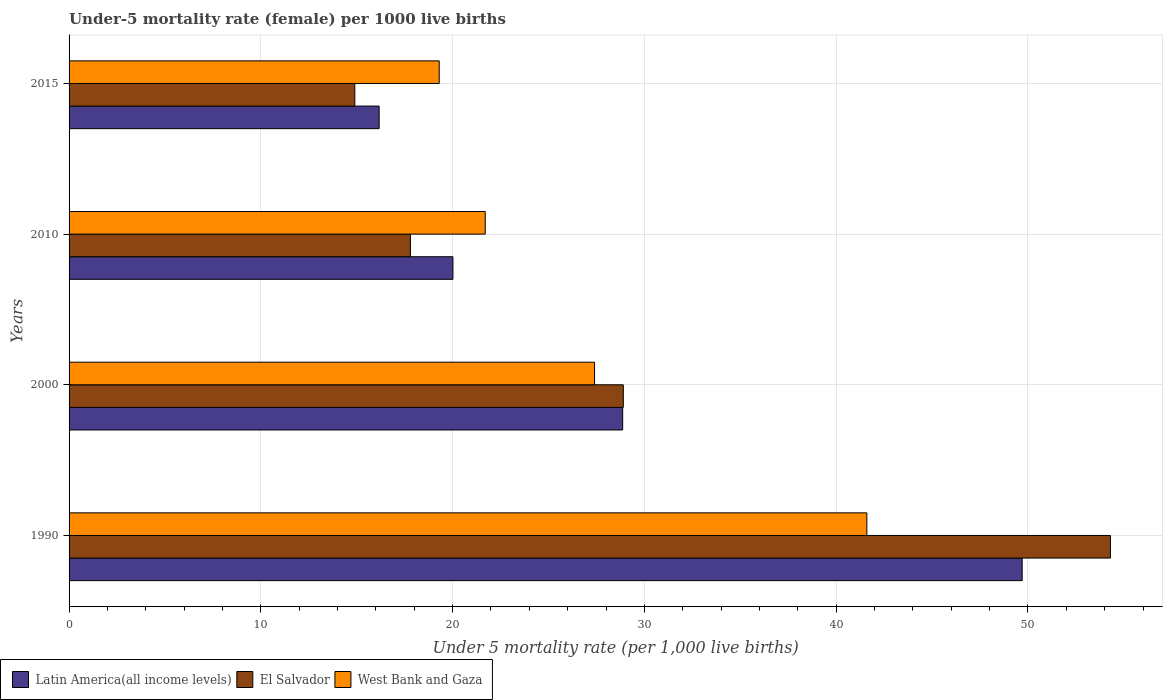Are the number of bars per tick equal to the number of legend labels?
Keep it short and to the point. Yes. How many bars are there on the 4th tick from the bottom?
Provide a short and direct response. 3. What is the label of the 2nd group of bars from the top?
Ensure brevity in your answer.  2010. In how many cases, is the number of bars for a given year not equal to the number of legend labels?
Your answer should be very brief. 0. What is the under-five mortality rate in Latin America(all income levels) in 2015?
Give a very brief answer. 16.17. Across all years, what is the maximum under-five mortality rate in Latin America(all income levels)?
Provide a succinct answer. 49.7. Across all years, what is the minimum under-five mortality rate in Latin America(all income levels)?
Provide a succinct answer. 16.17. In which year was the under-five mortality rate in West Bank and Gaza minimum?
Provide a short and direct response. 2015. What is the total under-five mortality rate in El Salvador in the graph?
Your answer should be compact. 115.9. What is the difference between the under-five mortality rate in El Salvador in 1990 and that in 2010?
Ensure brevity in your answer.  36.5. What is the difference between the under-five mortality rate in El Salvador in 1990 and the under-five mortality rate in West Bank and Gaza in 2010?
Keep it short and to the point. 32.6. What is the average under-five mortality rate in El Salvador per year?
Offer a terse response. 28.97. In the year 2015, what is the difference between the under-five mortality rate in El Salvador and under-five mortality rate in West Bank and Gaza?
Make the answer very short. -4.4. What is the ratio of the under-five mortality rate in West Bank and Gaza in 1990 to that in 2010?
Provide a succinct answer. 1.92. Is the under-five mortality rate in El Salvador in 2010 less than that in 2015?
Your response must be concise. No. Is the difference between the under-five mortality rate in El Salvador in 1990 and 2015 greater than the difference between the under-five mortality rate in West Bank and Gaza in 1990 and 2015?
Provide a short and direct response. Yes. What is the difference between the highest and the second highest under-five mortality rate in Latin America(all income levels)?
Your answer should be very brief. 20.83. What is the difference between the highest and the lowest under-five mortality rate in Latin America(all income levels)?
Keep it short and to the point. 33.53. In how many years, is the under-five mortality rate in West Bank and Gaza greater than the average under-five mortality rate in West Bank and Gaza taken over all years?
Make the answer very short. 1. Is the sum of the under-five mortality rate in West Bank and Gaza in 1990 and 2010 greater than the maximum under-five mortality rate in El Salvador across all years?
Make the answer very short. Yes. What does the 1st bar from the top in 1990 represents?
Your response must be concise. West Bank and Gaza. What does the 2nd bar from the bottom in 2010 represents?
Your answer should be compact. El Salvador. Is it the case that in every year, the sum of the under-five mortality rate in Latin America(all income levels) and under-five mortality rate in West Bank and Gaza is greater than the under-five mortality rate in El Salvador?
Your answer should be very brief. Yes. How many bars are there?
Provide a succinct answer. 12. Are all the bars in the graph horizontal?
Your response must be concise. Yes. What is the difference between two consecutive major ticks on the X-axis?
Your response must be concise. 10. Does the graph contain grids?
Ensure brevity in your answer.  Yes. What is the title of the graph?
Offer a very short reply. Under-5 mortality rate (female) per 1000 live births. Does "China" appear as one of the legend labels in the graph?
Your response must be concise. No. What is the label or title of the X-axis?
Keep it short and to the point. Under 5 mortality rate (per 1,0 live births). What is the Under 5 mortality rate (per 1,000 live births) in Latin America(all income levels) in 1990?
Give a very brief answer. 49.7. What is the Under 5 mortality rate (per 1,000 live births) of El Salvador in 1990?
Your answer should be very brief. 54.3. What is the Under 5 mortality rate (per 1,000 live births) of West Bank and Gaza in 1990?
Your answer should be compact. 41.6. What is the Under 5 mortality rate (per 1,000 live births) in Latin America(all income levels) in 2000?
Your answer should be very brief. 28.87. What is the Under 5 mortality rate (per 1,000 live births) of El Salvador in 2000?
Give a very brief answer. 28.9. What is the Under 5 mortality rate (per 1,000 live births) in West Bank and Gaza in 2000?
Make the answer very short. 27.4. What is the Under 5 mortality rate (per 1,000 live births) in Latin America(all income levels) in 2010?
Provide a short and direct response. 20.02. What is the Under 5 mortality rate (per 1,000 live births) in West Bank and Gaza in 2010?
Keep it short and to the point. 21.7. What is the Under 5 mortality rate (per 1,000 live births) of Latin America(all income levels) in 2015?
Your answer should be very brief. 16.17. What is the Under 5 mortality rate (per 1,000 live births) in West Bank and Gaza in 2015?
Give a very brief answer. 19.3. Across all years, what is the maximum Under 5 mortality rate (per 1,000 live births) in Latin America(all income levels)?
Provide a succinct answer. 49.7. Across all years, what is the maximum Under 5 mortality rate (per 1,000 live births) in El Salvador?
Give a very brief answer. 54.3. Across all years, what is the maximum Under 5 mortality rate (per 1,000 live births) of West Bank and Gaza?
Your answer should be very brief. 41.6. Across all years, what is the minimum Under 5 mortality rate (per 1,000 live births) of Latin America(all income levels)?
Your answer should be very brief. 16.17. Across all years, what is the minimum Under 5 mortality rate (per 1,000 live births) of El Salvador?
Give a very brief answer. 14.9. Across all years, what is the minimum Under 5 mortality rate (per 1,000 live births) of West Bank and Gaza?
Provide a succinct answer. 19.3. What is the total Under 5 mortality rate (per 1,000 live births) of Latin America(all income levels) in the graph?
Provide a succinct answer. 114.75. What is the total Under 5 mortality rate (per 1,000 live births) of El Salvador in the graph?
Your response must be concise. 115.9. What is the total Under 5 mortality rate (per 1,000 live births) of West Bank and Gaza in the graph?
Your response must be concise. 110. What is the difference between the Under 5 mortality rate (per 1,000 live births) of Latin America(all income levels) in 1990 and that in 2000?
Offer a terse response. 20.83. What is the difference between the Under 5 mortality rate (per 1,000 live births) of El Salvador in 1990 and that in 2000?
Your response must be concise. 25.4. What is the difference between the Under 5 mortality rate (per 1,000 live births) in Latin America(all income levels) in 1990 and that in 2010?
Offer a terse response. 29.68. What is the difference between the Under 5 mortality rate (per 1,000 live births) of El Salvador in 1990 and that in 2010?
Give a very brief answer. 36.5. What is the difference between the Under 5 mortality rate (per 1,000 live births) of Latin America(all income levels) in 1990 and that in 2015?
Your response must be concise. 33.53. What is the difference between the Under 5 mortality rate (per 1,000 live births) of El Salvador in 1990 and that in 2015?
Make the answer very short. 39.4. What is the difference between the Under 5 mortality rate (per 1,000 live births) of West Bank and Gaza in 1990 and that in 2015?
Your answer should be very brief. 22.3. What is the difference between the Under 5 mortality rate (per 1,000 live births) in Latin America(all income levels) in 2000 and that in 2010?
Offer a very short reply. 8.85. What is the difference between the Under 5 mortality rate (per 1,000 live births) in West Bank and Gaza in 2000 and that in 2010?
Ensure brevity in your answer.  5.7. What is the difference between the Under 5 mortality rate (per 1,000 live births) in Latin America(all income levels) in 2000 and that in 2015?
Ensure brevity in your answer.  12.7. What is the difference between the Under 5 mortality rate (per 1,000 live births) in Latin America(all income levels) in 2010 and that in 2015?
Keep it short and to the point. 3.85. What is the difference between the Under 5 mortality rate (per 1,000 live births) of West Bank and Gaza in 2010 and that in 2015?
Your answer should be compact. 2.4. What is the difference between the Under 5 mortality rate (per 1,000 live births) in Latin America(all income levels) in 1990 and the Under 5 mortality rate (per 1,000 live births) in El Salvador in 2000?
Offer a very short reply. 20.8. What is the difference between the Under 5 mortality rate (per 1,000 live births) in Latin America(all income levels) in 1990 and the Under 5 mortality rate (per 1,000 live births) in West Bank and Gaza in 2000?
Make the answer very short. 22.3. What is the difference between the Under 5 mortality rate (per 1,000 live births) in El Salvador in 1990 and the Under 5 mortality rate (per 1,000 live births) in West Bank and Gaza in 2000?
Make the answer very short. 26.9. What is the difference between the Under 5 mortality rate (per 1,000 live births) in Latin America(all income levels) in 1990 and the Under 5 mortality rate (per 1,000 live births) in El Salvador in 2010?
Offer a very short reply. 31.9. What is the difference between the Under 5 mortality rate (per 1,000 live births) of Latin America(all income levels) in 1990 and the Under 5 mortality rate (per 1,000 live births) of West Bank and Gaza in 2010?
Your answer should be compact. 28. What is the difference between the Under 5 mortality rate (per 1,000 live births) in El Salvador in 1990 and the Under 5 mortality rate (per 1,000 live births) in West Bank and Gaza in 2010?
Provide a short and direct response. 32.6. What is the difference between the Under 5 mortality rate (per 1,000 live births) in Latin America(all income levels) in 1990 and the Under 5 mortality rate (per 1,000 live births) in El Salvador in 2015?
Make the answer very short. 34.8. What is the difference between the Under 5 mortality rate (per 1,000 live births) of Latin America(all income levels) in 1990 and the Under 5 mortality rate (per 1,000 live births) of West Bank and Gaza in 2015?
Your answer should be very brief. 30.4. What is the difference between the Under 5 mortality rate (per 1,000 live births) of Latin America(all income levels) in 2000 and the Under 5 mortality rate (per 1,000 live births) of El Salvador in 2010?
Ensure brevity in your answer.  11.07. What is the difference between the Under 5 mortality rate (per 1,000 live births) in Latin America(all income levels) in 2000 and the Under 5 mortality rate (per 1,000 live births) in West Bank and Gaza in 2010?
Provide a short and direct response. 7.17. What is the difference between the Under 5 mortality rate (per 1,000 live births) in El Salvador in 2000 and the Under 5 mortality rate (per 1,000 live births) in West Bank and Gaza in 2010?
Your answer should be compact. 7.2. What is the difference between the Under 5 mortality rate (per 1,000 live births) of Latin America(all income levels) in 2000 and the Under 5 mortality rate (per 1,000 live births) of El Salvador in 2015?
Give a very brief answer. 13.97. What is the difference between the Under 5 mortality rate (per 1,000 live births) in Latin America(all income levels) in 2000 and the Under 5 mortality rate (per 1,000 live births) in West Bank and Gaza in 2015?
Make the answer very short. 9.57. What is the difference between the Under 5 mortality rate (per 1,000 live births) of El Salvador in 2000 and the Under 5 mortality rate (per 1,000 live births) of West Bank and Gaza in 2015?
Keep it short and to the point. 9.6. What is the difference between the Under 5 mortality rate (per 1,000 live births) in Latin America(all income levels) in 2010 and the Under 5 mortality rate (per 1,000 live births) in El Salvador in 2015?
Give a very brief answer. 5.12. What is the difference between the Under 5 mortality rate (per 1,000 live births) in Latin America(all income levels) in 2010 and the Under 5 mortality rate (per 1,000 live births) in West Bank and Gaza in 2015?
Ensure brevity in your answer.  0.72. What is the average Under 5 mortality rate (per 1,000 live births) of Latin America(all income levels) per year?
Offer a very short reply. 28.69. What is the average Under 5 mortality rate (per 1,000 live births) of El Salvador per year?
Provide a succinct answer. 28.98. What is the average Under 5 mortality rate (per 1,000 live births) of West Bank and Gaza per year?
Keep it short and to the point. 27.5. In the year 1990, what is the difference between the Under 5 mortality rate (per 1,000 live births) of Latin America(all income levels) and Under 5 mortality rate (per 1,000 live births) of El Salvador?
Offer a very short reply. -4.6. In the year 1990, what is the difference between the Under 5 mortality rate (per 1,000 live births) in Latin America(all income levels) and Under 5 mortality rate (per 1,000 live births) in West Bank and Gaza?
Keep it short and to the point. 8.1. In the year 2000, what is the difference between the Under 5 mortality rate (per 1,000 live births) of Latin America(all income levels) and Under 5 mortality rate (per 1,000 live births) of El Salvador?
Give a very brief answer. -0.03. In the year 2000, what is the difference between the Under 5 mortality rate (per 1,000 live births) of Latin America(all income levels) and Under 5 mortality rate (per 1,000 live births) of West Bank and Gaza?
Your response must be concise. 1.47. In the year 2010, what is the difference between the Under 5 mortality rate (per 1,000 live births) of Latin America(all income levels) and Under 5 mortality rate (per 1,000 live births) of El Salvador?
Offer a very short reply. 2.22. In the year 2010, what is the difference between the Under 5 mortality rate (per 1,000 live births) of Latin America(all income levels) and Under 5 mortality rate (per 1,000 live births) of West Bank and Gaza?
Keep it short and to the point. -1.68. In the year 2010, what is the difference between the Under 5 mortality rate (per 1,000 live births) in El Salvador and Under 5 mortality rate (per 1,000 live births) in West Bank and Gaza?
Offer a very short reply. -3.9. In the year 2015, what is the difference between the Under 5 mortality rate (per 1,000 live births) of Latin America(all income levels) and Under 5 mortality rate (per 1,000 live births) of El Salvador?
Make the answer very short. 1.27. In the year 2015, what is the difference between the Under 5 mortality rate (per 1,000 live births) of Latin America(all income levels) and Under 5 mortality rate (per 1,000 live births) of West Bank and Gaza?
Your answer should be compact. -3.13. In the year 2015, what is the difference between the Under 5 mortality rate (per 1,000 live births) of El Salvador and Under 5 mortality rate (per 1,000 live births) of West Bank and Gaza?
Your answer should be very brief. -4.4. What is the ratio of the Under 5 mortality rate (per 1,000 live births) of Latin America(all income levels) in 1990 to that in 2000?
Provide a short and direct response. 1.72. What is the ratio of the Under 5 mortality rate (per 1,000 live births) in El Salvador in 1990 to that in 2000?
Provide a succinct answer. 1.88. What is the ratio of the Under 5 mortality rate (per 1,000 live births) of West Bank and Gaza in 1990 to that in 2000?
Provide a short and direct response. 1.52. What is the ratio of the Under 5 mortality rate (per 1,000 live births) of Latin America(all income levels) in 1990 to that in 2010?
Provide a short and direct response. 2.48. What is the ratio of the Under 5 mortality rate (per 1,000 live births) in El Salvador in 1990 to that in 2010?
Give a very brief answer. 3.05. What is the ratio of the Under 5 mortality rate (per 1,000 live births) of West Bank and Gaza in 1990 to that in 2010?
Provide a succinct answer. 1.92. What is the ratio of the Under 5 mortality rate (per 1,000 live births) of Latin America(all income levels) in 1990 to that in 2015?
Provide a succinct answer. 3.07. What is the ratio of the Under 5 mortality rate (per 1,000 live births) of El Salvador in 1990 to that in 2015?
Provide a succinct answer. 3.64. What is the ratio of the Under 5 mortality rate (per 1,000 live births) in West Bank and Gaza in 1990 to that in 2015?
Offer a very short reply. 2.16. What is the ratio of the Under 5 mortality rate (per 1,000 live births) in Latin America(all income levels) in 2000 to that in 2010?
Your response must be concise. 1.44. What is the ratio of the Under 5 mortality rate (per 1,000 live births) of El Salvador in 2000 to that in 2010?
Your answer should be very brief. 1.62. What is the ratio of the Under 5 mortality rate (per 1,000 live births) of West Bank and Gaza in 2000 to that in 2010?
Your answer should be compact. 1.26. What is the ratio of the Under 5 mortality rate (per 1,000 live births) of Latin America(all income levels) in 2000 to that in 2015?
Your response must be concise. 1.79. What is the ratio of the Under 5 mortality rate (per 1,000 live births) of El Salvador in 2000 to that in 2015?
Give a very brief answer. 1.94. What is the ratio of the Under 5 mortality rate (per 1,000 live births) of West Bank and Gaza in 2000 to that in 2015?
Your response must be concise. 1.42. What is the ratio of the Under 5 mortality rate (per 1,000 live births) of Latin America(all income levels) in 2010 to that in 2015?
Offer a terse response. 1.24. What is the ratio of the Under 5 mortality rate (per 1,000 live births) of El Salvador in 2010 to that in 2015?
Offer a very short reply. 1.19. What is the ratio of the Under 5 mortality rate (per 1,000 live births) in West Bank and Gaza in 2010 to that in 2015?
Your response must be concise. 1.12. What is the difference between the highest and the second highest Under 5 mortality rate (per 1,000 live births) in Latin America(all income levels)?
Ensure brevity in your answer.  20.83. What is the difference between the highest and the second highest Under 5 mortality rate (per 1,000 live births) in El Salvador?
Offer a very short reply. 25.4. What is the difference between the highest and the second highest Under 5 mortality rate (per 1,000 live births) of West Bank and Gaza?
Ensure brevity in your answer.  14.2. What is the difference between the highest and the lowest Under 5 mortality rate (per 1,000 live births) of Latin America(all income levels)?
Your answer should be compact. 33.53. What is the difference between the highest and the lowest Under 5 mortality rate (per 1,000 live births) in El Salvador?
Make the answer very short. 39.4. What is the difference between the highest and the lowest Under 5 mortality rate (per 1,000 live births) of West Bank and Gaza?
Offer a terse response. 22.3. 